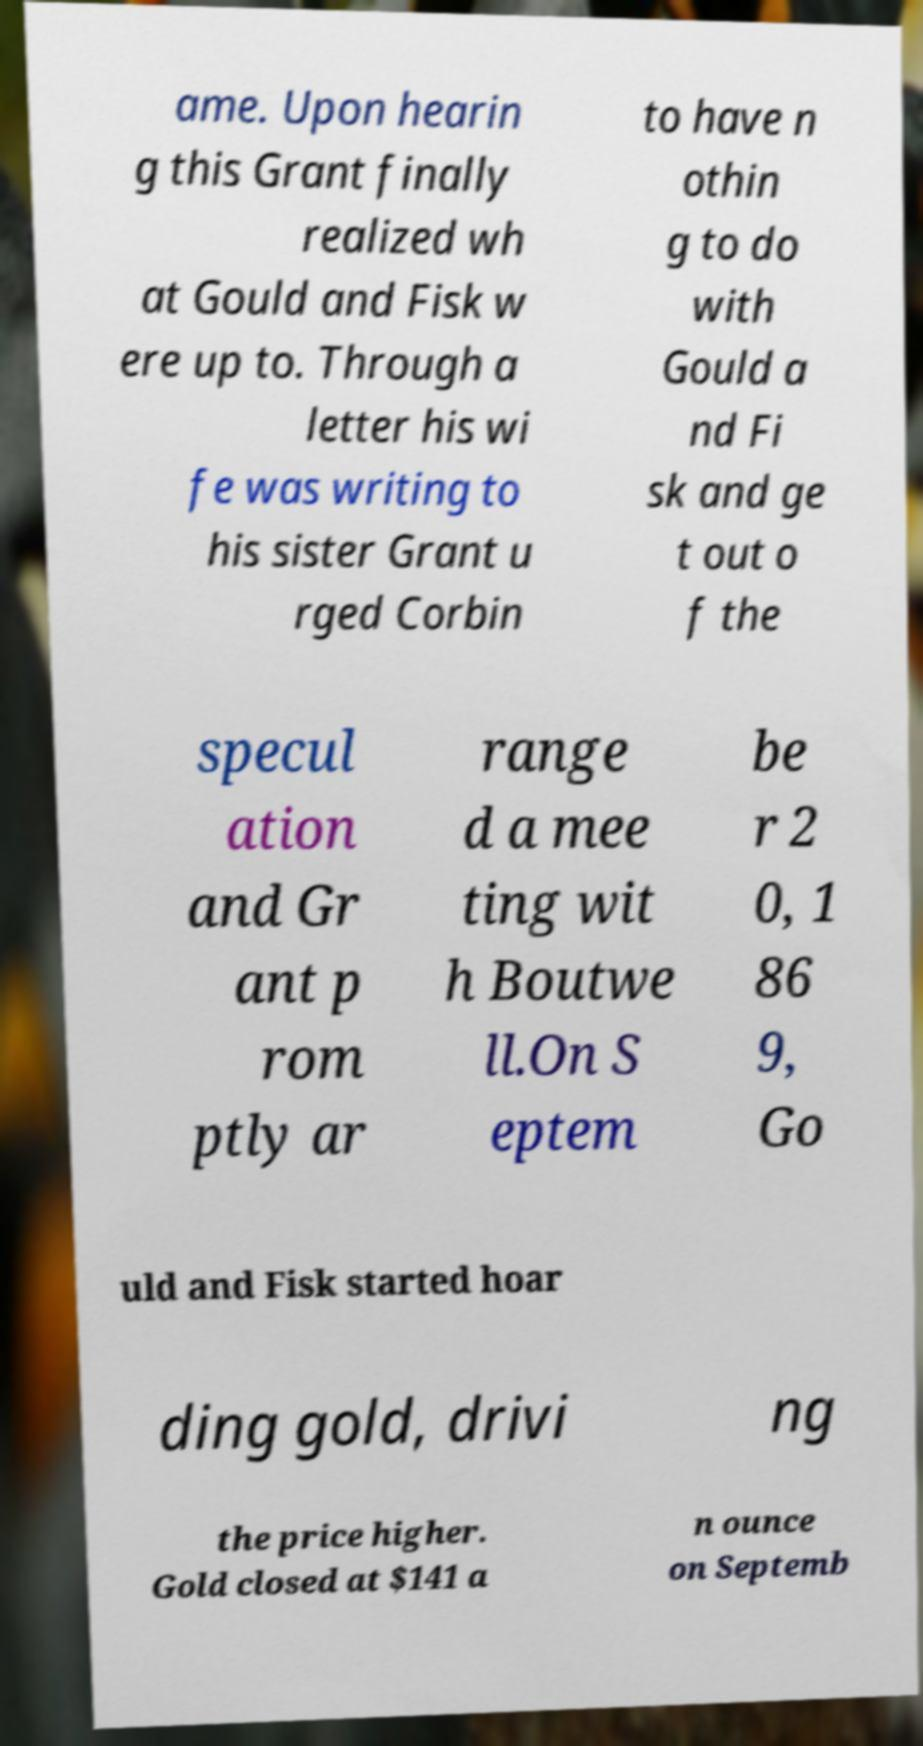For documentation purposes, I need the text within this image transcribed. Could you provide that? ame. Upon hearin g this Grant finally realized wh at Gould and Fisk w ere up to. Through a letter his wi fe was writing to his sister Grant u rged Corbin to have n othin g to do with Gould a nd Fi sk and ge t out o f the specul ation and Gr ant p rom ptly ar range d a mee ting wit h Boutwe ll.On S eptem be r 2 0, 1 86 9, Go uld and Fisk started hoar ding gold, drivi ng the price higher. Gold closed at $141 a n ounce on Septemb 